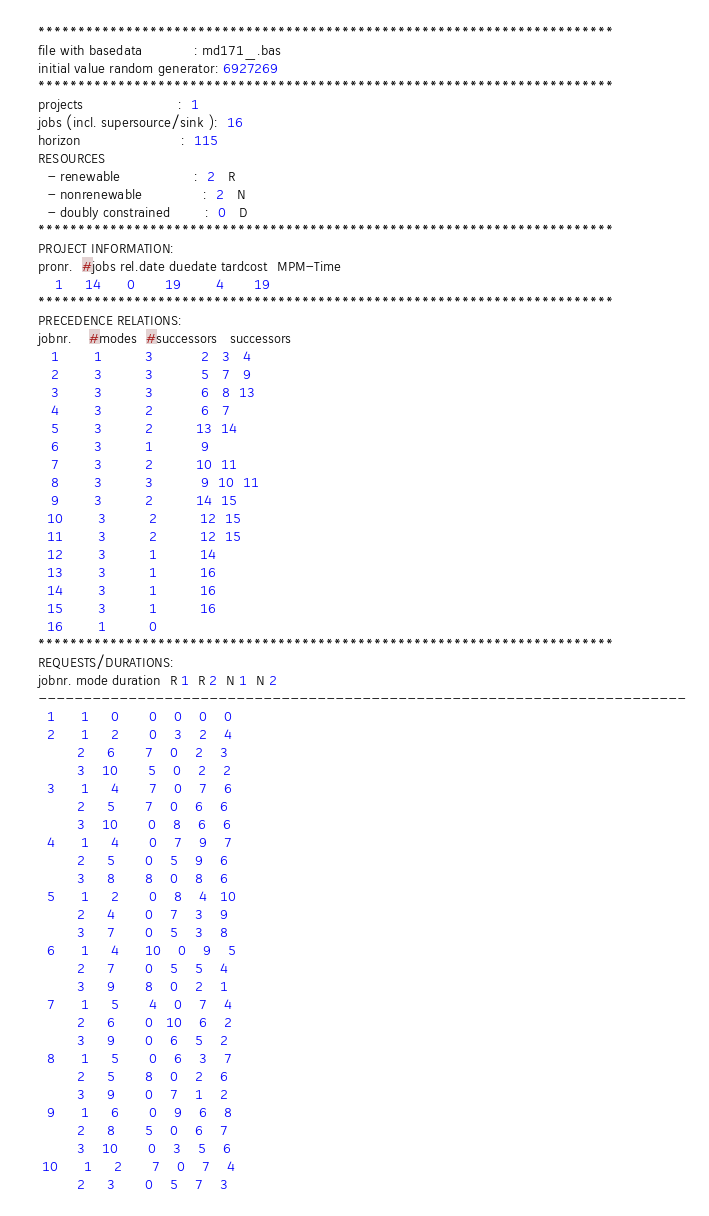Convert code to text. <code><loc_0><loc_0><loc_500><loc_500><_ObjectiveC_>************************************************************************
file with basedata            : md171_.bas
initial value random generator: 6927269
************************************************************************
projects                      :  1
jobs (incl. supersource/sink ):  16
horizon                       :  115
RESOURCES
  - renewable                 :  2   R
  - nonrenewable              :  2   N
  - doubly constrained        :  0   D
************************************************************************
PROJECT INFORMATION:
pronr.  #jobs rel.date duedate tardcost  MPM-Time
    1     14      0       19        4       19
************************************************************************
PRECEDENCE RELATIONS:
jobnr.    #modes  #successors   successors
   1        1          3           2   3   4
   2        3          3           5   7   9
   3        3          3           6   8  13
   4        3          2           6   7
   5        3          2          13  14
   6        3          1           9
   7        3          2          10  11
   8        3          3           9  10  11
   9        3          2          14  15
  10        3          2          12  15
  11        3          2          12  15
  12        3          1          14
  13        3          1          16
  14        3          1          16
  15        3          1          16
  16        1          0        
************************************************************************
REQUESTS/DURATIONS:
jobnr. mode duration  R 1  R 2  N 1  N 2
------------------------------------------------------------------------
  1      1     0       0    0    0    0
  2      1     2       0    3    2    4
         2     6       7    0    2    3
         3    10       5    0    2    2
  3      1     4       7    0    7    6
         2     5       7    0    6    6
         3    10       0    8    6    6
  4      1     4       0    7    9    7
         2     5       0    5    9    6
         3     8       8    0    8    6
  5      1     2       0    8    4   10
         2     4       0    7    3    9
         3     7       0    5    3    8
  6      1     4      10    0    9    5
         2     7       0    5    5    4
         3     9       8    0    2    1
  7      1     5       4    0    7    4
         2     6       0   10    6    2
         3     9       0    6    5    2
  8      1     5       0    6    3    7
         2     5       8    0    2    6
         3     9       0    7    1    2
  9      1     6       0    9    6    8
         2     8       5    0    6    7
         3    10       0    3    5    6
 10      1     2       7    0    7    4
         2     3       0    5    7    3</code> 